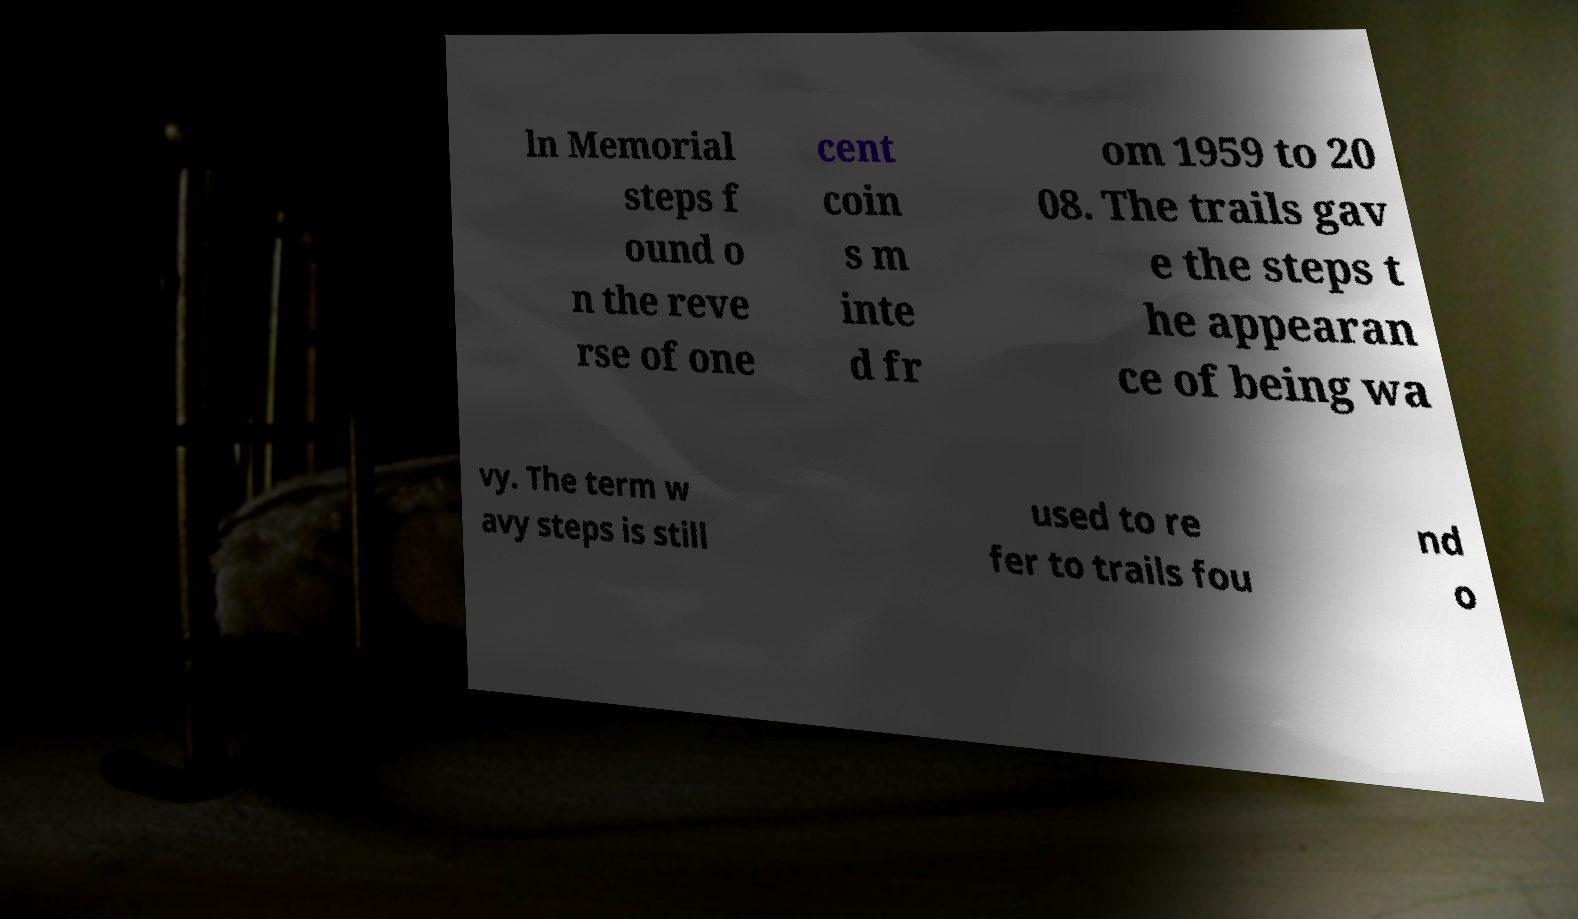For documentation purposes, I need the text within this image transcribed. Could you provide that? ln Memorial steps f ound o n the reve rse of one cent coin s m inte d fr om 1959 to 20 08. The trails gav e the steps t he appearan ce of being wa vy. The term w avy steps is still used to re fer to trails fou nd o 